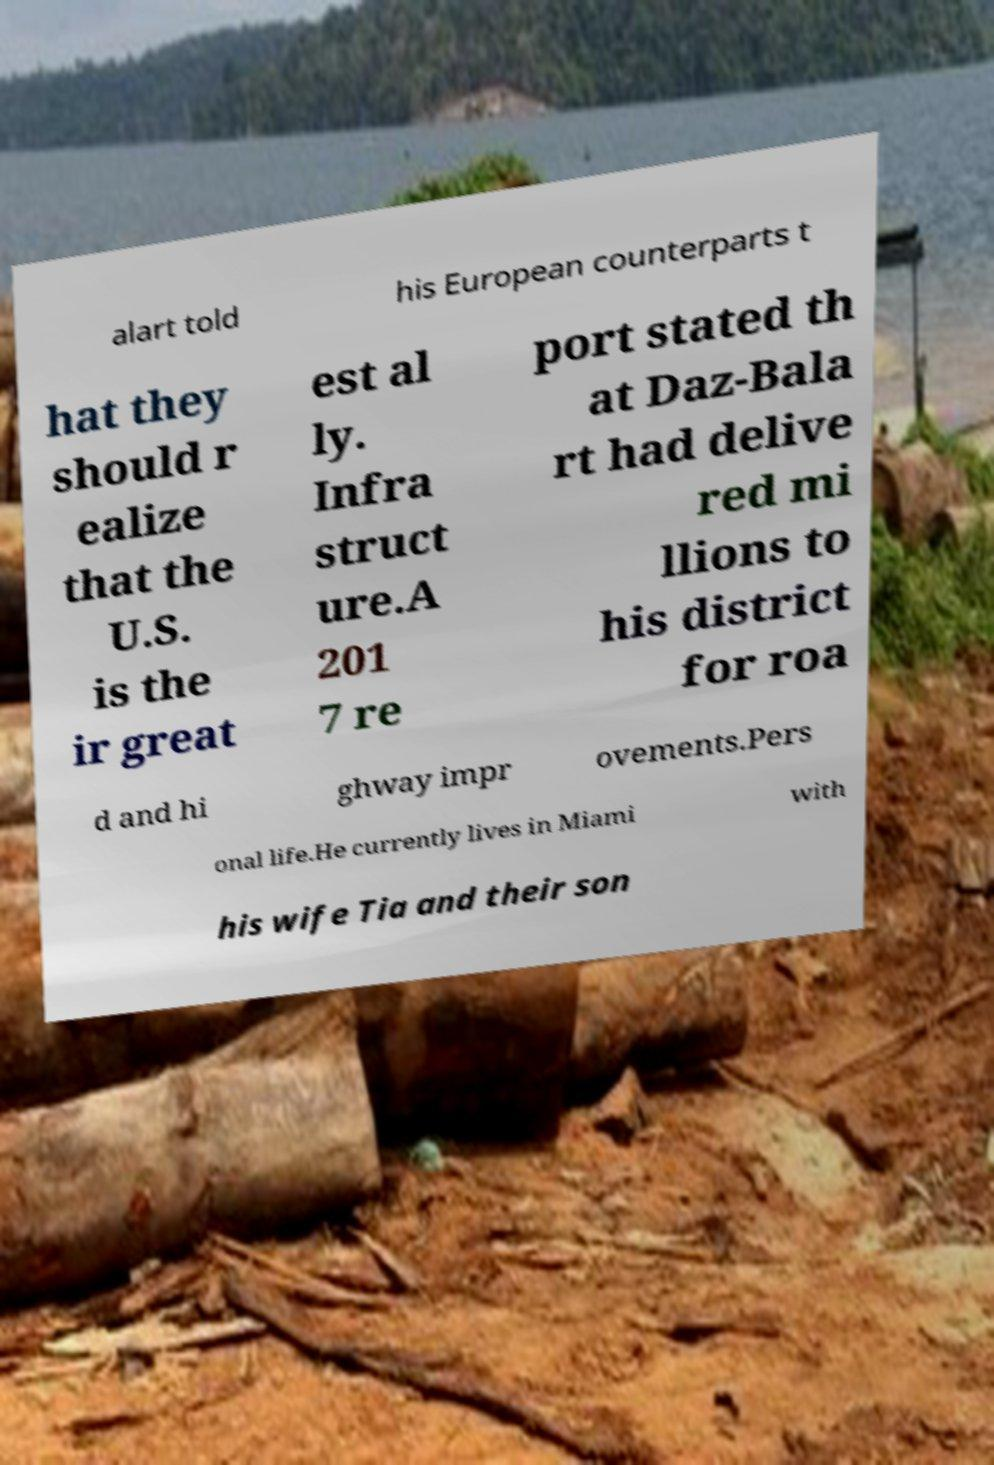Can you accurately transcribe the text from the provided image for me? alart told his European counterparts t hat they should r ealize that the U.S. is the ir great est al ly. Infra struct ure.A 201 7 re port stated th at Daz-Bala rt had delive red mi llions to his district for roa d and hi ghway impr ovements.Pers onal life.He currently lives in Miami with his wife Tia and their son 